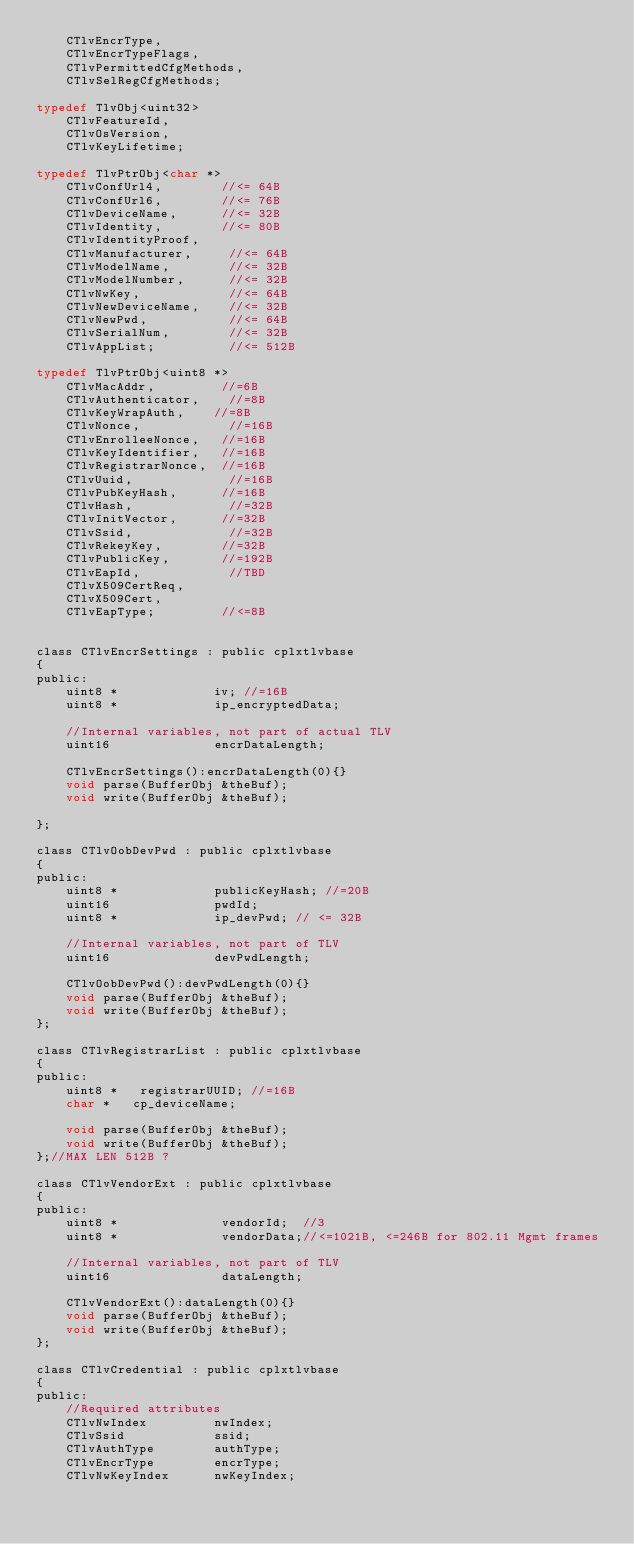Convert code to text. <code><loc_0><loc_0><loc_500><loc_500><_C_>    CTlvEncrType,
    CTlvEncrTypeFlags,
    CTlvPermittedCfgMethods,
    CTlvSelRegCfgMethods;

typedef TlvObj<uint32>
    CTlvFeatureId,
    CTlvOsVersion,
    CTlvKeyLifetime;

typedef TlvPtrObj<char *>
    CTlvConfUrl4,        //<= 64B
    CTlvConfUrl6,        //<= 76B
    CTlvDeviceName,      //<= 32B
    CTlvIdentity,        //<= 80B
    CTlvIdentityProof,
    CTlvManufacturer,     //<= 64B
    CTlvModelName,        //<= 32B
    CTlvModelNumber,      //<= 32B
    CTlvNwKey,            //<= 64B
    CTlvNewDeviceName,    //<= 32B
    CTlvNewPwd,           //<= 64B
    CTlvSerialNum,        //<= 32B
    CTlvAppList;          //<= 512B

typedef TlvPtrObj<uint8 *>
    CTlvMacAddr,         //=6B
    CTlvAuthenticator,    //=8B
    CTlvKeyWrapAuth,    //=8B
    CTlvNonce,            //=16B
    CTlvEnrolleeNonce,   //=16B
    CTlvKeyIdentifier,   //=16B
    CTlvRegistrarNonce,  //=16B
    CTlvUuid,             //=16B
    CTlvPubKeyHash,      //=16B
    CTlvHash,             //=32B
    CTlvInitVector,      //=32B
    CTlvSsid,             //=32B
    CTlvRekeyKey,        //=32B
    CTlvPublicKey,       //=192B
    CTlvEapId,            //TBD
    CTlvX509CertReq,
    CTlvX509Cert,
    CTlvEapType;         //<=8B


class CTlvEncrSettings : public cplxtlvbase
{
public:
    uint8 *             iv; //=16B
    uint8 *             ip_encryptedData; 

    //Internal variables, not part of actual TLV
    uint16              encrDataLength; 

    CTlvEncrSettings():encrDataLength(0){}
    void parse(BufferObj &theBuf);
    void write(BufferObj &theBuf);

};

class CTlvOobDevPwd : public cplxtlvbase
{
public:
    uint8 *             publicKeyHash; //=20B
    uint16              pwdId;
    uint8 *             ip_devPwd; // <= 32B

    //Internal variables, not part of TLV
    uint16              devPwdLength;

    CTlvOobDevPwd():devPwdLength(0){}
    void parse(BufferObj &theBuf);
    void write(BufferObj &theBuf);
};

class CTlvRegistrarList : public cplxtlvbase
{
public:
    uint8 *   registrarUUID; //=16B
    char *   cp_deviceName;

    void parse(BufferObj &theBuf);
    void write(BufferObj &theBuf);
};//MAX LEN 512B ?    

class CTlvVendorExt : public cplxtlvbase
{
public:
    uint8 *              vendorId;  //3
    uint8 *              vendorData;//<=1021B, <=246B for 802.11 Mgmt frames

    //Internal variables, not part of TLV
    uint16               dataLength;

    CTlvVendorExt():dataLength(0){}
    void parse(BufferObj &theBuf);
    void write(BufferObj &theBuf);
};    

class CTlvCredential : public cplxtlvbase
{
public:
    //Required attributes
    CTlvNwIndex         nwIndex;
    CTlvSsid            ssid;
    CTlvAuthType        authType;
    CTlvEncrType        encrType;
    CTlvNwKeyIndex      nwKeyIndex;</code> 